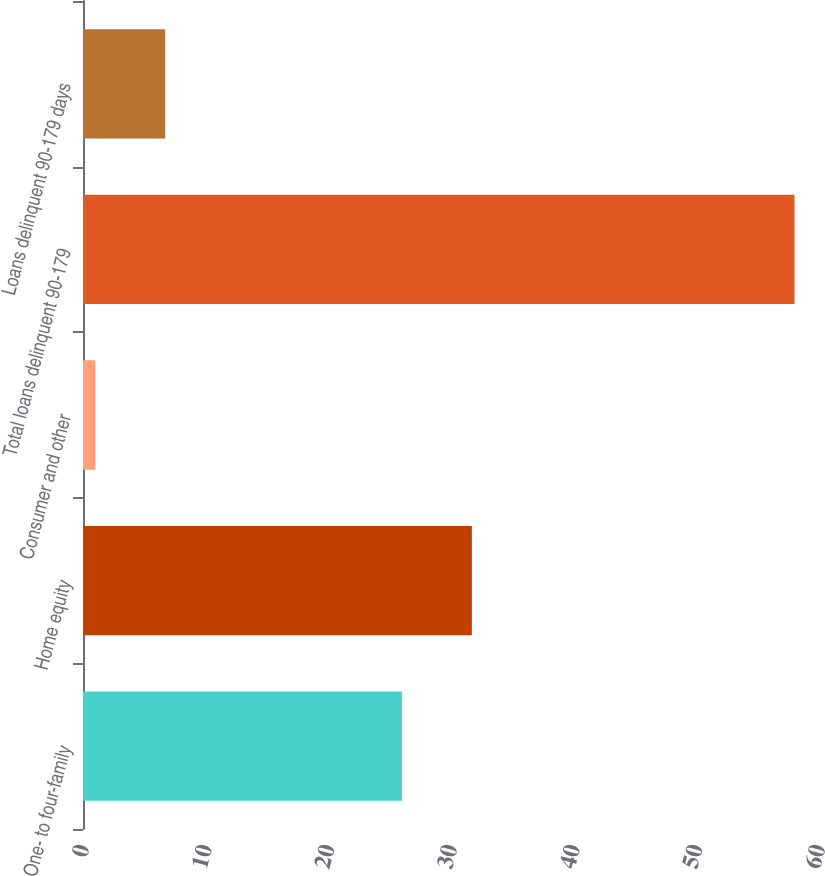Convert chart. <chart><loc_0><loc_0><loc_500><loc_500><bar_chart><fcel>One- to four-family<fcel>Home equity<fcel>Consumer and other<fcel>Total loans delinquent 90-179<fcel>Loans delinquent 90-179 days<nl><fcel>26<fcel>31.7<fcel>1<fcel>58<fcel>6.7<nl></chart> 